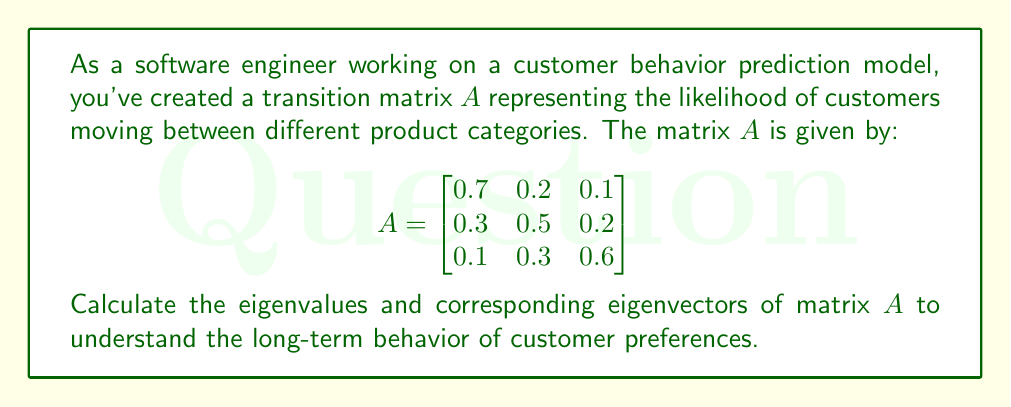What is the answer to this math problem? To find the eigenvalues and eigenvectors of matrix $A$, we'll follow these steps:

1. Find the characteristic equation:
   $det(A - \lambda I) = 0$

   $$\begin{vmatrix}
   0.7 - \lambda & 0.2 & 0.1 \\
   0.3 & 0.5 - \lambda & 0.2 \\
   0.1 & 0.3 & 0.6 - \lambda
   \end{vmatrix} = 0$$

2. Expand the determinant:
   $(0.7 - \lambda)[(0.5 - \lambda)(0.6 - \lambda) - 0.06] - 0.2[0.3(0.6 - \lambda) - 0.02] + 0.1[0.3(0.5 - \lambda) - 0.06] = 0$

3. Simplify:
   $-\lambda^3 + 1.8\lambda^2 - 0.98\lambda + 0.16 = 0$

4. Solve the cubic equation (using a calculator or computer algebra system):
   $\lambda_1 = 1$
   $\lambda_2 \approx 0.5$
   $\lambda_3 \approx 0.3$

5. For each eigenvalue, find the corresponding eigenvector by solving $(A - \lambda I)v = 0$:

   For $\lambda_1 = 1$:
   $$\begin{bmatrix}
   -0.3 & 0.2 & 0.1 \\
   0.3 & -0.5 & 0.2 \\
   0.1 & 0.3 & -0.4
   \end{bmatrix}\begin{bmatrix}
   v_1 \\ v_2 \\ v_3
   \end{bmatrix} = \begin{bmatrix}
   0 \\ 0 \\ 0
   \end{bmatrix}$$

   Solving this system gives: $v_1 \approx 0.4082, v_2 \approx 0.4082, v_3 \approx 0.8165$

   Repeat this process for $\lambda_2$ and $\lambda_3$ to find their corresponding eigenvectors.

6. Normalize the eigenvectors to unit length.
Answer: Eigenvalues: $\lambda_1 = 1, \lambda_2 \approx 0.5, \lambda_3 \approx 0.3$
Eigenvectors (normalized):
$v_1 \approx (0.4082, 0.4082, 0.8165)^T$
$v_2$ and $v_3$ can be calculated similarly. 